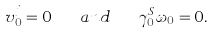<formula> <loc_0><loc_0><loc_500><loc_500>v ^ { j } _ { 0 } = 0 \quad a n d \quad \gamma _ { 0 } ^ { S } \omega _ { 0 } = 0 .</formula> 